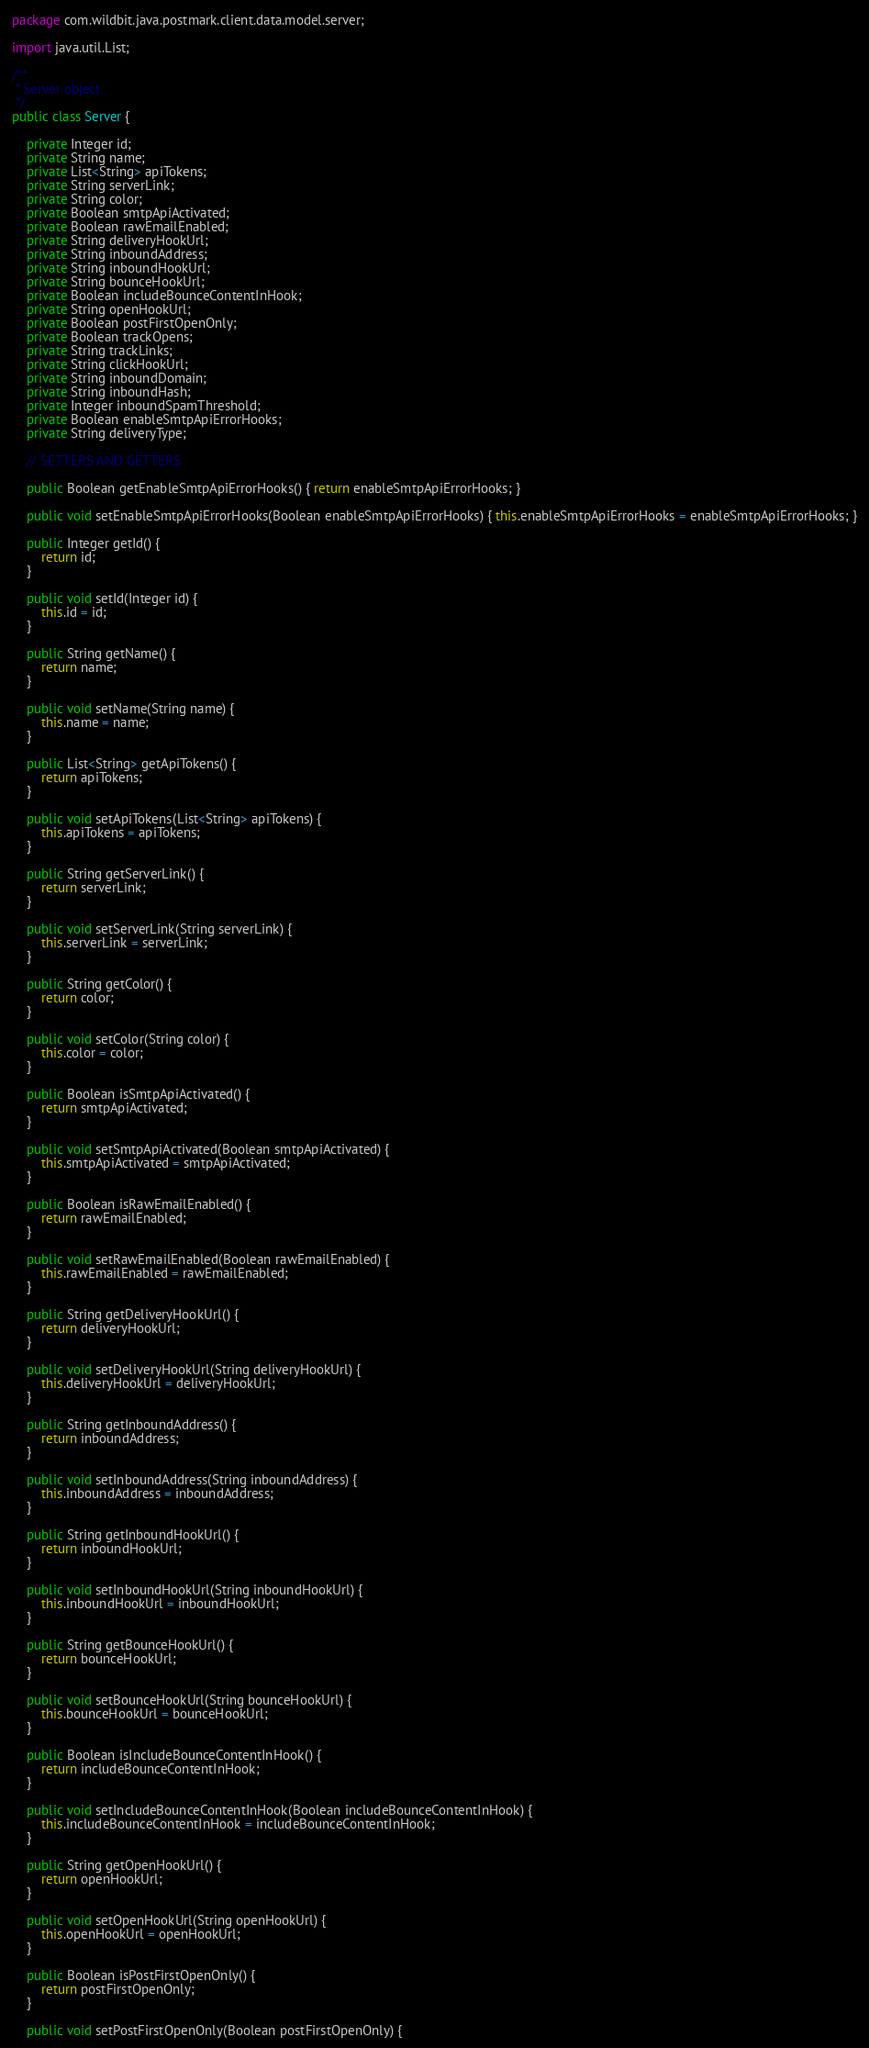Convert code to text. <code><loc_0><loc_0><loc_500><loc_500><_Java_>package com.wildbit.java.postmark.client.data.model.server;

import java.util.List;

/**
 * Server object.
 */
public class Server {

    private Integer id;
    private String name;
    private List<String> apiTokens;
    private String serverLink;
    private String color;
    private Boolean smtpApiActivated;
    private Boolean rawEmailEnabled;
    private String deliveryHookUrl;
    private String inboundAddress;
    private String inboundHookUrl;
    private String bounceHookUrl;
    private Boolean includeBounceContentInHook;
    private String openHookUrl;
    private Boolean postFirstOpenOnly;
    private Boolean trackOpens;
    private String trackLinks;
    private String clickHookUrl;
    private String inboundDomain;
    private String inboundHash;
    private Integer inboundSpamThreshold;
    private Boolean enableSmtpApiErrorHooks;
    private String deliveryType;

    // SETTERS AND GETTERS

    public Boolean getEnableSmtpApiErrorHooks() { return enableSmtpApiErrorHooks; }

    public void setEnableSmtpApiErrorHooks(Boolean enableSmtpApiErrorHooks) { this.enableSmtpApiErrorHooks = enableSmtpApiErrorHooks; }

    public Integer getId() {
        return id;
    }

    public void setId(Integer id) {
        this.id = id;
    }

    public String getName() {
        return name;
    }

    public void setName(String name) {
        this.name = name;
    }

    public List<String> getApiTokens() {
        return apiTokens;
    }

    public void setApiTokens(List<String> apiTokens) {
        this.apiTokens = apiTokens;
    }

    public String getServerLink() {
        return serverLink;
    }

    public void setServerLink(String serverLink) {
        this.serverLink = serverLink;
    }

    public String getColor() {
        return color;
    }

    public void setColor(String color) {
        this.color = color;
    }

    public Boolean isSmtpApiActivated() {
        return smtpApiActivated;
    }

    public void setSmtpApiActivated(Boolean smtpApiActivated) {
        this.smtpApiActivated = smtpApiActivated;
    }

    public Boolean isRawEmailEnabled() {
        return rawEmailEnabled;
    }

    public void setRawEmailEnabled(Boolean rawEmailEnabled) {
        this.rawEmailEnabled = rawEmailEnabled;
    }

    public String getDeliveryHookUrl() {
        return deliveryHookUrl;
    }

    public void setDeliveryHookUrl(String deliveryHookUrl) {
        this.deliveryHookUrl = deliveryHookUrl;
    }

    public String getInboundAddress() {
        return inboundAddress;
    }

    public void setInboundAddress(String inboundAddress) {
        this.inboundAddress = inboundAddress;
    }

    public String getInboundHookUrl() {
        return inboundHookUrl;
    }

    public void setInboundHookUrl(String inboundHookUrl) {
        this.inboundHookUrl = inboundHookUrl;
    }

    public String getBounceHookUrl() {
        return bounceHookUrl;
    }

    public void setBounceHookUrl(String bounceHookUrl) {
        this.bounceHookUrl = bounceHookUrl;
    }

    public Boolean isIncludeBounceContentInHook() {
        return includeBounceContentInHook;
    }

    public void setIncludeBounceContentInHook(Boolean includeBounceContentInHook) {
        this.includeBounceContentInHook = includeBounceContentInHook;
    }

    public String getOpenHookUrl() {
        return openHookUrl;
    }

    public void setOpenHookUrl(String openHookUrl) {
        this.openHookUrl = openHookUrl;
    }

    public Boolean isPostFirstOpenOnly() {
        return postFirstOpenOnly;
    }

    public void setPostFirstOpenOnly(Boolean postFirstOpenOnly) {</code> 